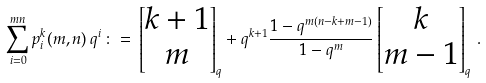Convert formula to latex. <formula><loc_0><loc_0><loc_500><loc_500>\sum _ { i = 0 } ^ { m n } p ^ { k } _ { i } ( m , n ) \, q ^ { i } \, \colon = \, \begin{bmatrix} k + 1 \\ m \end{bmatrix} _ { q } + q ^ { k + 1 } \frac { 1 - q ^ { m ( n - k + m - 1 ) } } { 1 - q ^ { m } } \begin{bmatrix} k \\ m - 1 \end{bmatrix} _ { q } \, .</formula> 